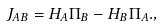<formula> <loc_0><loc_0><loc_500><loc_500>\ J _ { A B } = H _ { A } \Pi _ { B } - H _ { B } \Pi _ { A } . ,</formula> 